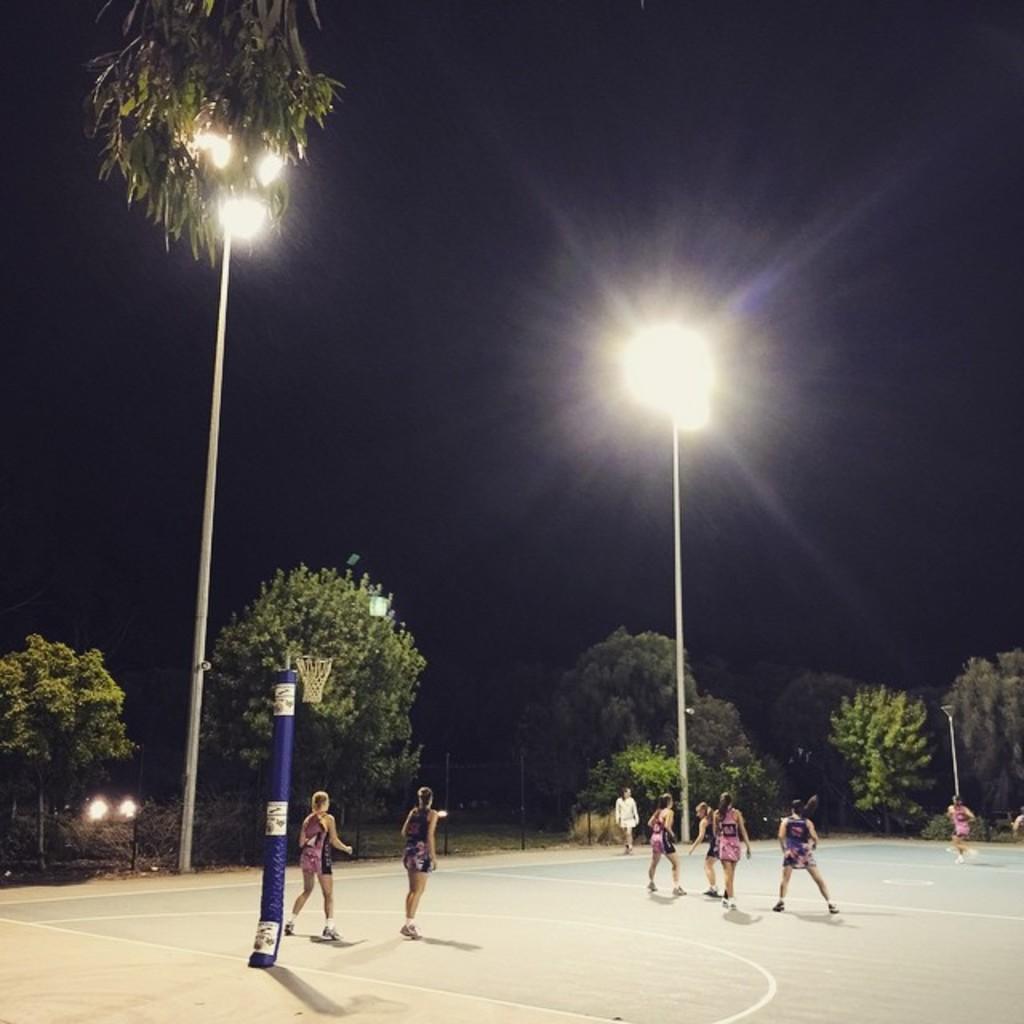How would you summarize this image in a sentence or two? In this picture there are group of pole and there are trees and there is a basket on the pole and there are street lights. At the top there is sky. At the bottom there is a floor and there is a fence. 